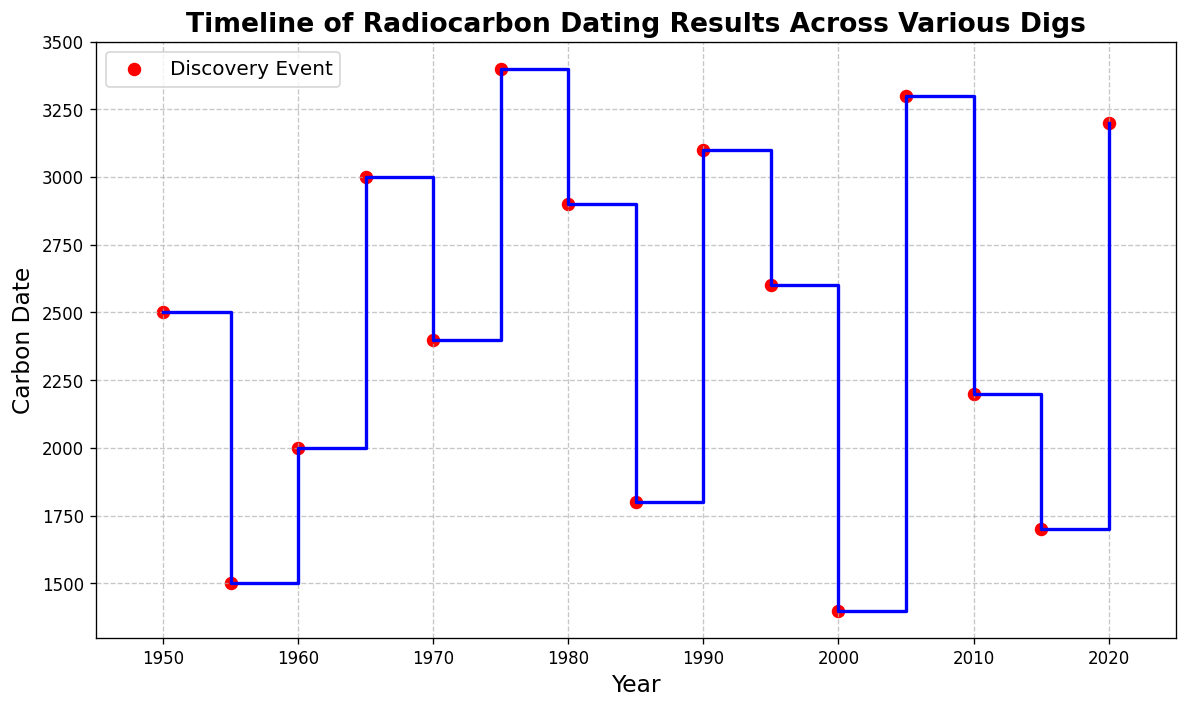What is the range of the carbon dates depicted in the plot? The range is calculated by finding the difference between the highest and lowest carbon dates on the y-axis. The highest carbon date is 3400 (Site F, 1975) and the lowest is 1400 (Site K, 2000). The range is 3400 - 1400.
Answer: 2000 Which year had the highest carbon date? Observe the y-axis to see the highest point on the chart, which corresponds to a specific year on the x-axis. The highest carbon date is 3400 in 1975 (Site F).
Answer: 1975 On average, how frequently were discoveries made based on the timeline given? There are 15 discoveries made between 1950 and 2020. The total time span is 2020 - 1950 = 70 years. Dividing the time span by the number of discoveries provides the average frequency: 70 / 15.
Answer: 4.67 years per discovery Which two consecutive discoveries had the highest difference in carbon dating? Calculate the differences between carbon dates of consecutive discoveries and identify the pair with the maximum difference. The pairs are (2500-1500), (2000-2500), (3000-2000), (2400-3000), (3400-2400), (2900-3400), (1800-2900), (3100-1800), (2600-3100), (1400-2600), (3300-1400), (2200-3300), (1700-2200), (3200-1700). The largest difference occurs between 1300 (2005) and 3100 (1990), specifically (3300 - 1400).
Answer: 1900 How many discoveries have carbon dates higher than 3000? Count the number of points on the y-axis that are above the 3000 mark. The discoveries are at 3000, 3100, 3200, 3300, and 3400.
Answer: 5 